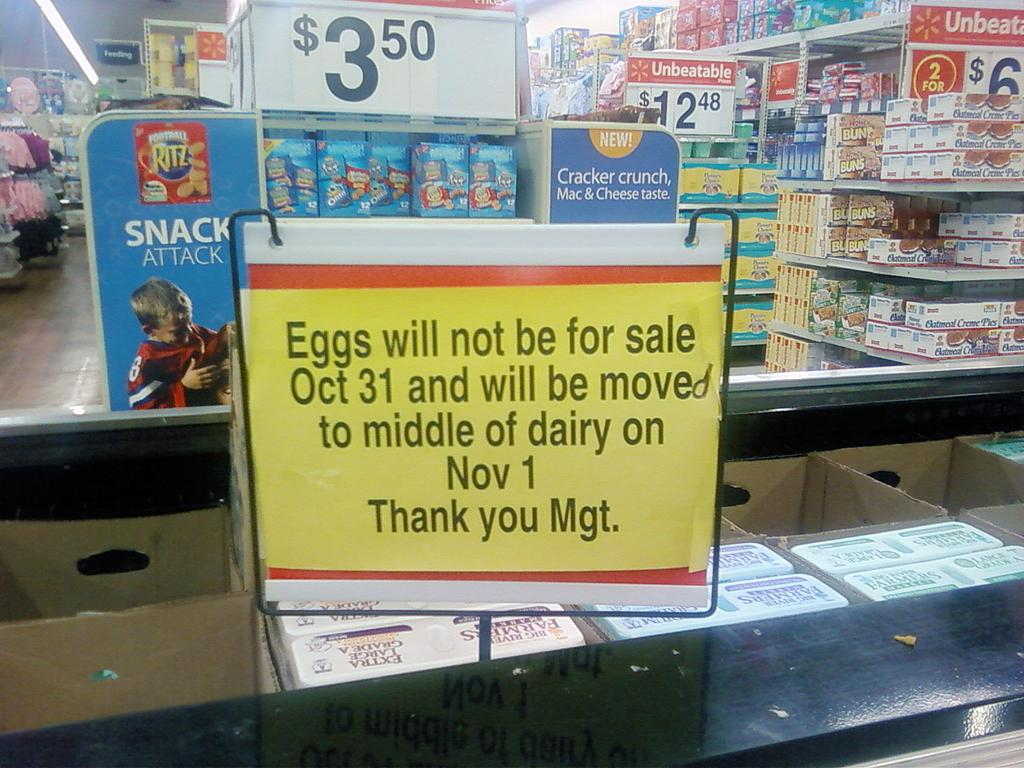<image>
Share a concise interpretation of the image provided. The sign in a grocery store indicates eggs are not available on October 31. 